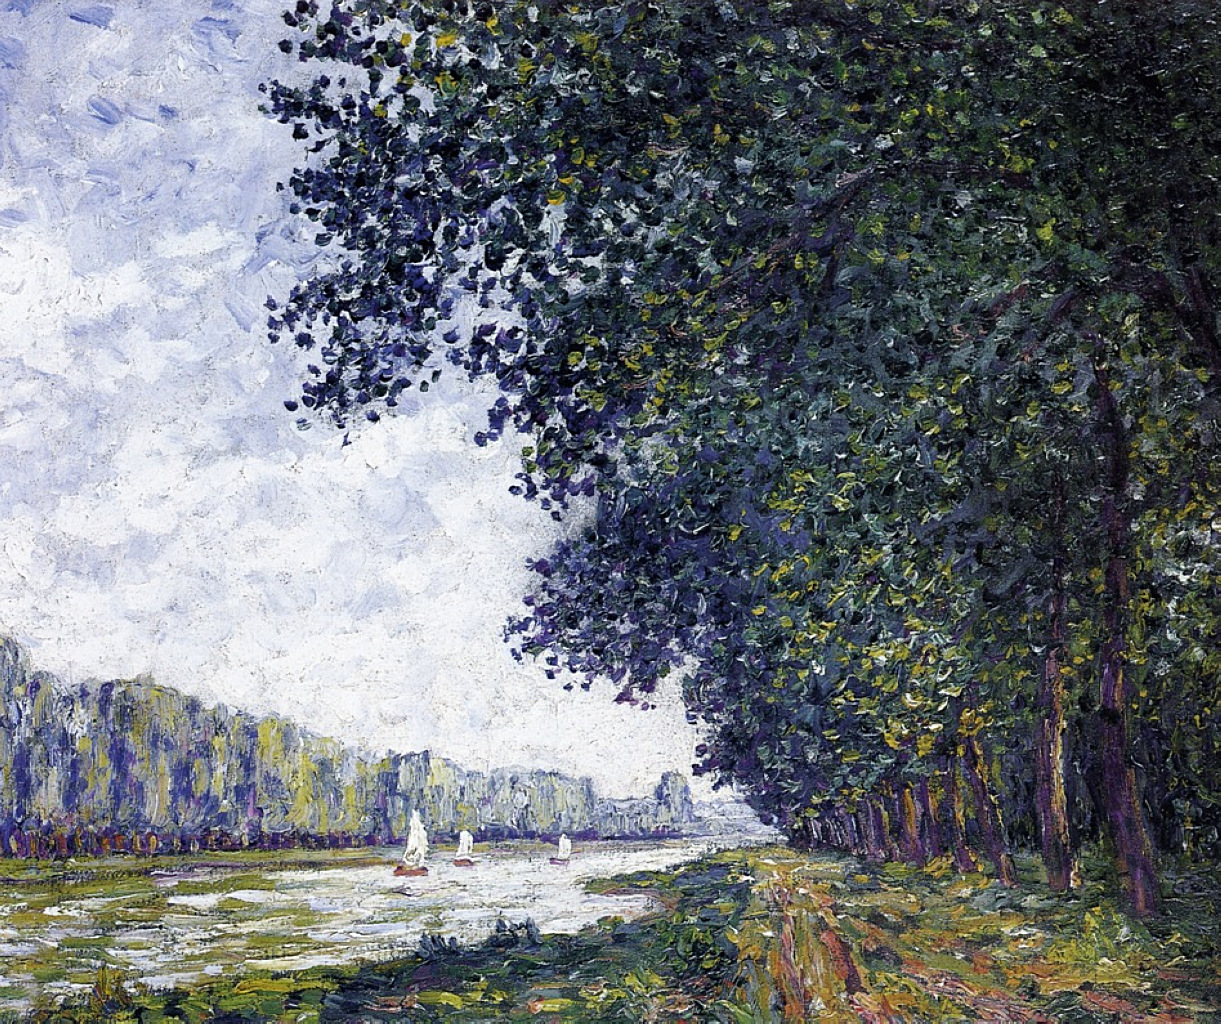What time of year does the scene in the painting seem to depict? The scene in the painting appears to depict late spring or early summer. The abundant and lush green foliage on the trees, as well as the clear and vibrant sky, suggests a time when nature is in full bloom. Additionally, the presence of people engaging in leisurely activities on the sailboats hints at a warmer, more pleasant time of year, perfect for outdoor enjoyment. How do the artist's brushstrokes affect the overall feel of the painting? The artist’s brushstrokes contribute significantly to the dynamic and lively feel of the painting. The visible strokes infuse the scene with a sense of movement and life, giving viewers the impression that the leaves are rustling in a gentle breeze, and that the water is softly rippling. This technique also adds texture and depth, enhancing the sensory experience of the viewer and inviting them to feel immersed in the natural surroundings depicted in the painting. Imagine the story behind this scene. What could be happening beyond the frame? Beyond the frame, one could imagine a picturesque countryside, with quaint cottages nestled among rolling hills. Farmers tend to their fields, while children play with kites in an open meadow. Nearby, a quaint village may be hosting a local market, with vibrant stalls and lively chatter. This detailed and tranquil rural setting adds a rich tapestry of life and activity beyond what is captured within the frame of the painting. 